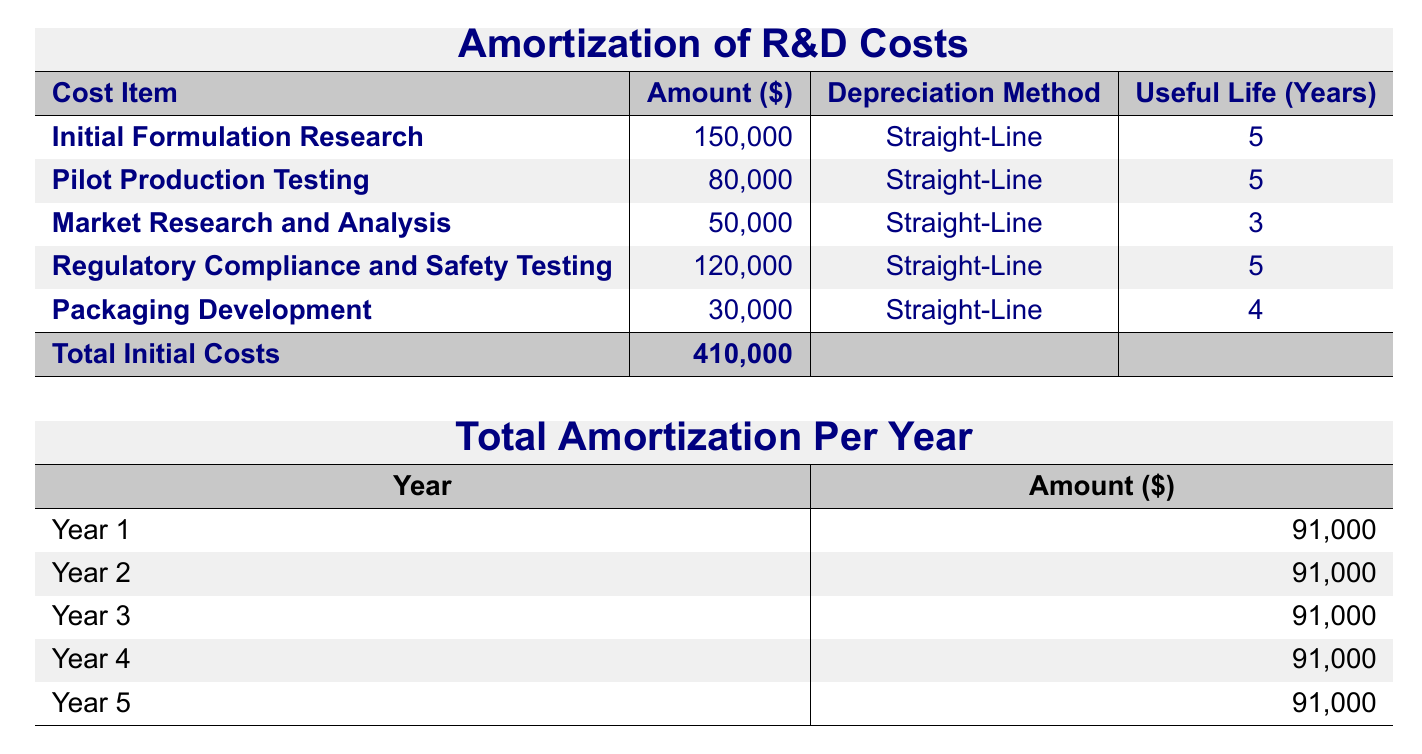What is the total amount allocated for Initial Formulation Research? The table lists "Initial Formulation Research" with an amount of 150,000. Therefore, the total allocated for this item is directly referenced from the table.
Answer: 150,000 How many years is the Useful Life for Pilot Production Testing? The table states that the Useful Life for "Pilot Production Testing" is 5 years, as indicated in the relevant column of the table.
Answer: 5 What is the total amortization amount for Year 3? According to the table, the total amortization for Year 3 is listed as 91,000. This value is explicitly stated in the corresponding section of the table.
Answer: 91,000 Is the amount for Regulatory Compliance and Safety Testing greater than the amount for Packaging Development? The amount for "Regulatory Compliance and Safety Testing" is 120,000 and for "Packaging Development" is 30,000. Since 120,000 is greater than 30,000, the answer is yes.
Answer: Yes What is the total amortization of all R&D costs over the 5 years? Each year’s amortization is 91,000 for 5 years, so the total amortization is 91,000 multiplied by 5, resulting in 455,000. This involves calculating the total from the yearly amounts given in the table.
Answer: 455,000 What is the average annual amortization amount? The total amortization over the 5 years is 455,000. To find the average, divide this total by 5 (years): 455,000 / 5 equals 91,000. This requires calculating the total and then dividing by the number of years.
Answer: 91,000 How much did we spend on Market Research and Analysis compared to Initial Formulation Research? The amount for "Market Research and Analysis" is 50,000, and for "Initial Formulation Research" it's 150,000. Comparing the two, 50,000 is less than 150,000. Therefore, the spending on Market Research and Analysis is less.
Answer: Less Is the Total Initial Costs equal to the sum of all individual R&D costs? The total initial costs are stated as 410,000. Adding all the individual costs (150,000 + 80,000 + 50,000 + 120,000 + 30,000) equals 410,000 as well, confirming the two amounts match. This involves summing all cost items listed in the table.
Answer: Yes What percentage of the total initial costs is attributed to Pilot Production Testing? The amount for "Pilot Production Testing" is 80,000. The percentage can be calculated as (80,000 / 410,000) * 100, equaling approximately 19.51%. This involves dividing and then multiplying by 100 to convert to a percentage.
Answer: 19.51% 